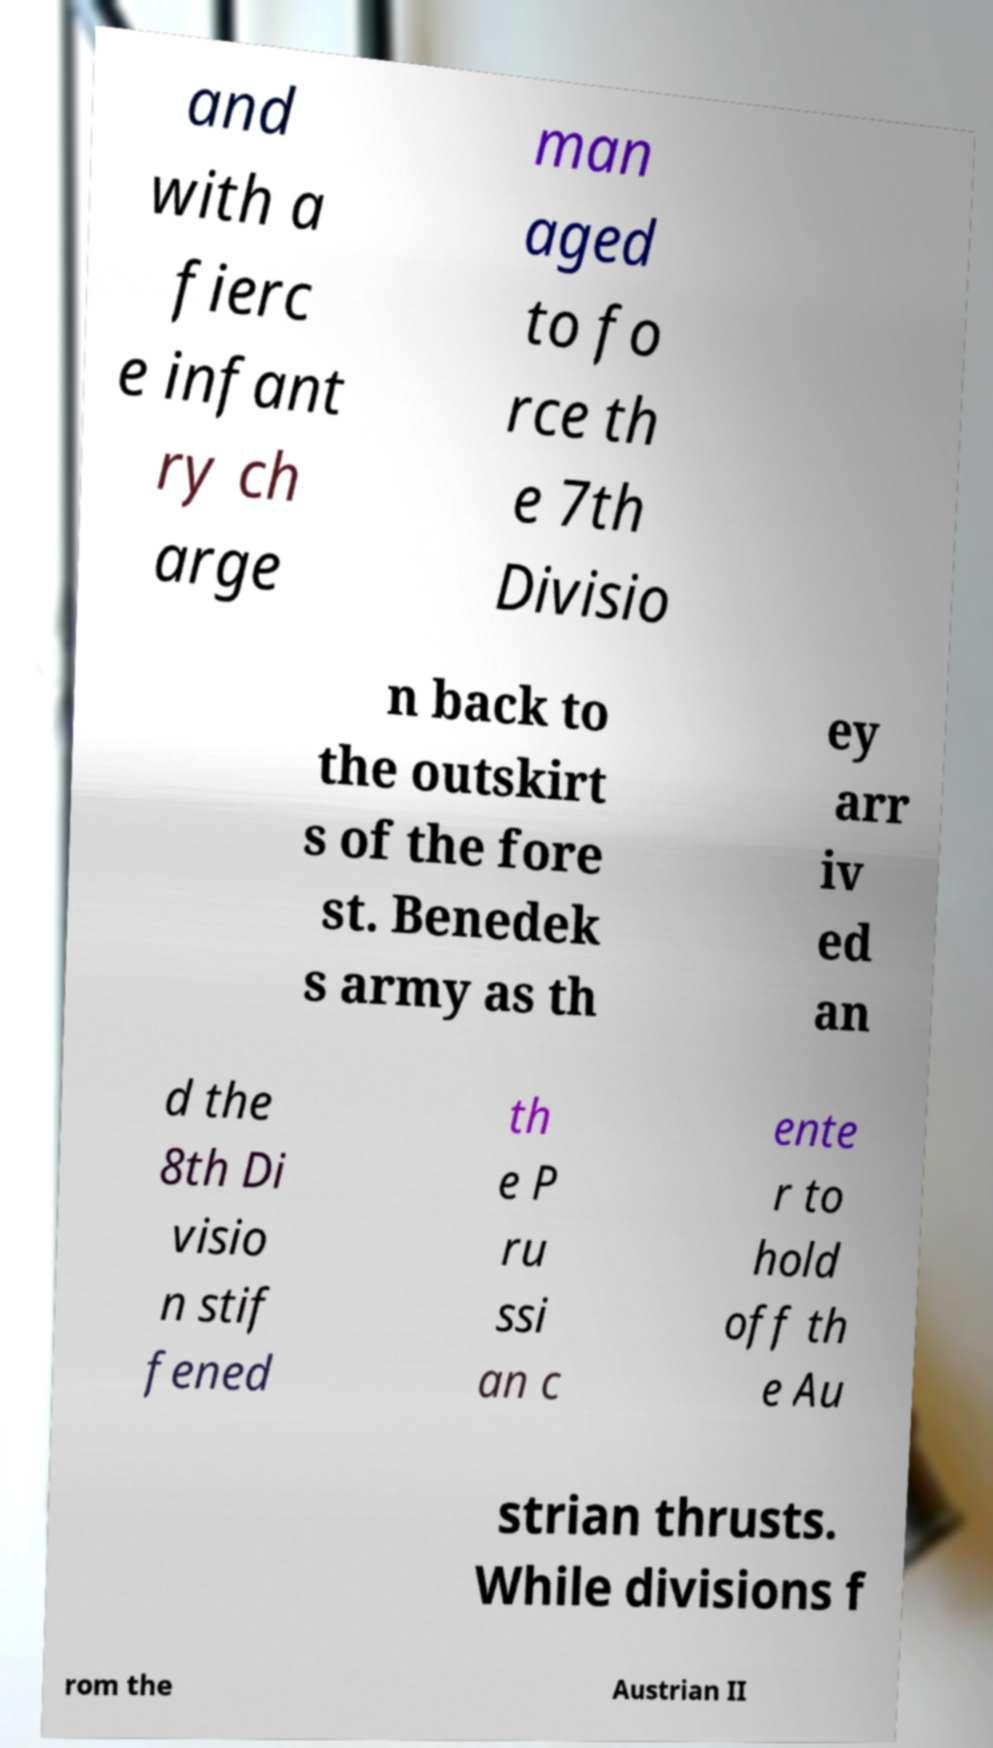Please read and relay the text visible in this image. What does it say? and with a fierc e infant ry ch arge man aged to fo rce th e 7th Divisio n back to the outskirt s of the fore st. Benedek s army as th ey arr iv ed an d the 8th Di visio n stif fened th e P ru ssi an c ente r to hold off th e Au strian thrusts. While divisions f rom the Austrian II 